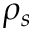Convert formula to latex. <formula><loc_0><loc_0><loc_500><loc_500>\rho _ { s }</formula> 